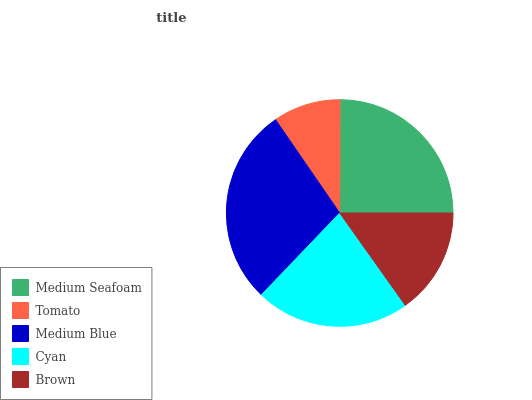Is Tomato the minimum?
Answer yes or no. Yes. Is Medium Blue the maximum?
Answer yes or no. Yes. Is Medium Blue the minimum?
Answer yes or no. No. Is Tomato the maximum?
Answer yes or no. No. Is Medium Blue greater than Tomato?
Answer yes or no. Yes. Is Tomato less than Medium Blue?
Answer yes or no. Yes. Is Tomato greater than Medium Blue?
Answer yes or no. No. Is Medium Blue less than Tomato?
Answer yes or no. No. Is Cyan the high median?
Answer yes or no. Yes. Is Cyan the low median?
Answer yes or no. Yes. Is Brown the high median?
Answer yes or no. No. Is Medium Blue the low median?
Answer yes or no. No. 